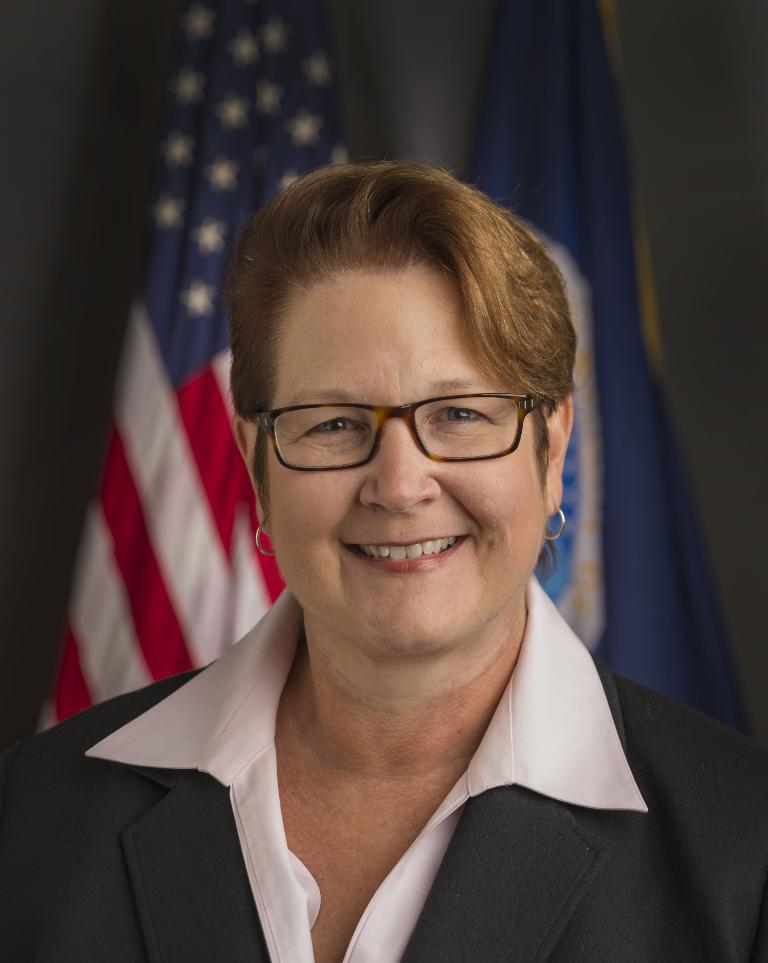Could you give a brief overview of what you see in this image? In this image we can see a woman wearing the glasses and smiling. In the background we can see the flags. 